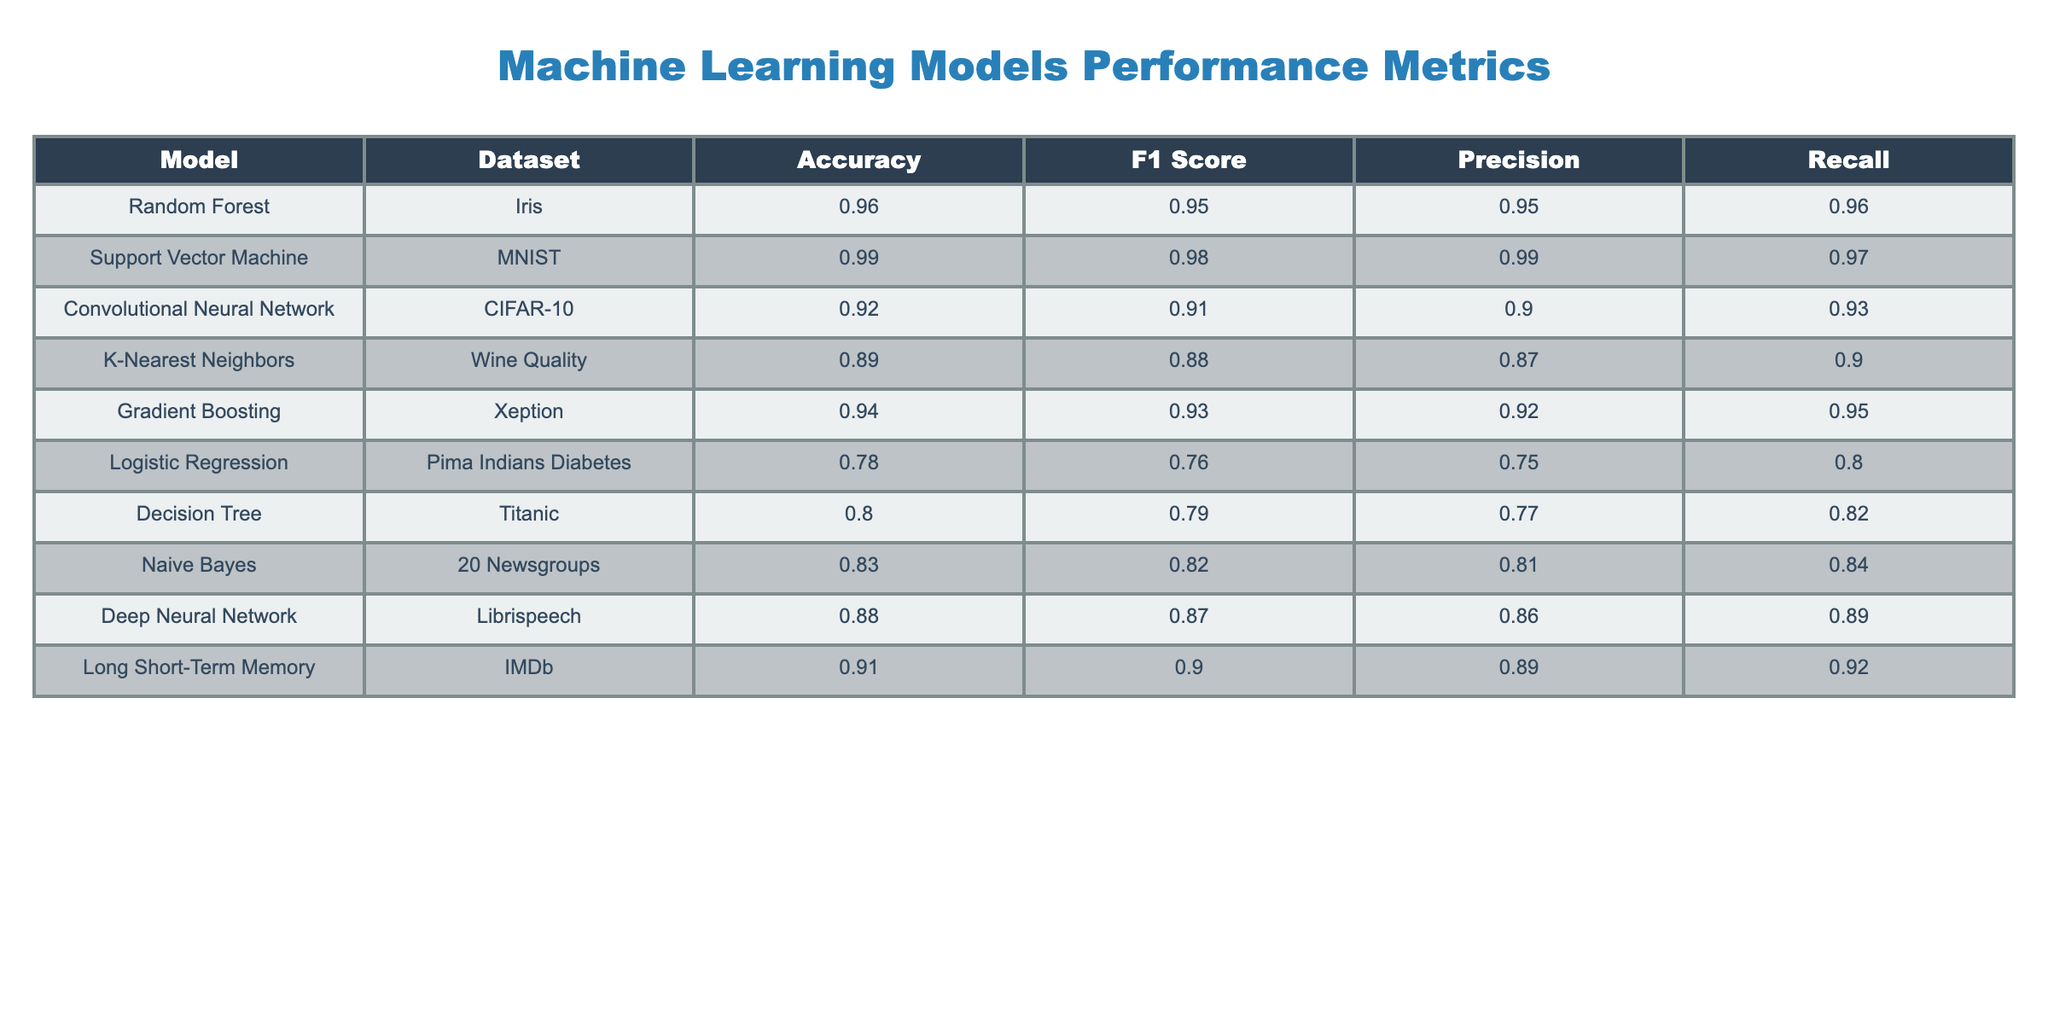What is the accuracy of the Support Vector Machine model on the MNIST dataset? The table directly lists the accuracy for each model on each dataset. Looking at the row for Support Vector Machine under the MNIST dataset, the value is 0.99.
Answer: 0.99 Which model achieved the highest F1 score? By examining the F1 scores for each model in the table, the Support Vector Machine model shows the highest score of 0.98 across all datasets.
Answer: 0.98 What is the average accuracy of the models listed? To find the average accuracy, sum all accuracy values: (0.96 + 0.99 + 0.92 + 0.89 + 0.94 + 0.78 + 0.80 + 0.83 + 0.88 + 0.91) = 9.10, then divide by the number of models, which is 10. Thus, the average is 9.10 / 10 = 0.91.
Answer: 0.91 Is the Precision of the Convolutional Neural Network greater than 0.85? The Precision value for the Convolutional Neural Network is 0.90, which is greater than 0.85. Thus, the fact holds true.
Answer: Yes Which model has the lowest Recall? To find the model with the lowest Recall, we compare the values in the Recall column. The Logistic Regression model shows the lowest Recall value of 0.80.
Answer: Logistic Regression 